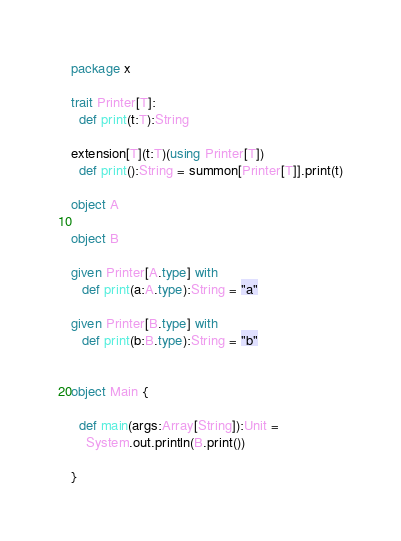Convert code to text. <code><loc_0><loc_0><loc_500><loc_500><_Scala_>package x

trait Printer[T]:
  def print(t:T):String

extension[T](t:T)(using Printer[T])
  def print():String = summon[Printer[T]].print(t)

object A

object B

given Printer[A.type] with
   def print(a:A.type):String = "a"

given Printer[B.type] with
   def print(b:B.type):String = "b"


object Main {

  def main(args:Array[String]):Unit =
    System.out.println(B.print())

}
</code> 